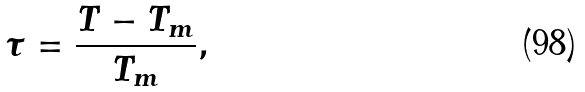<formula> <loc_0><loc_0><loc_500><loc_500>\tau = \frac { T - T _ { m } } { T _ { m } } ,</formula> 